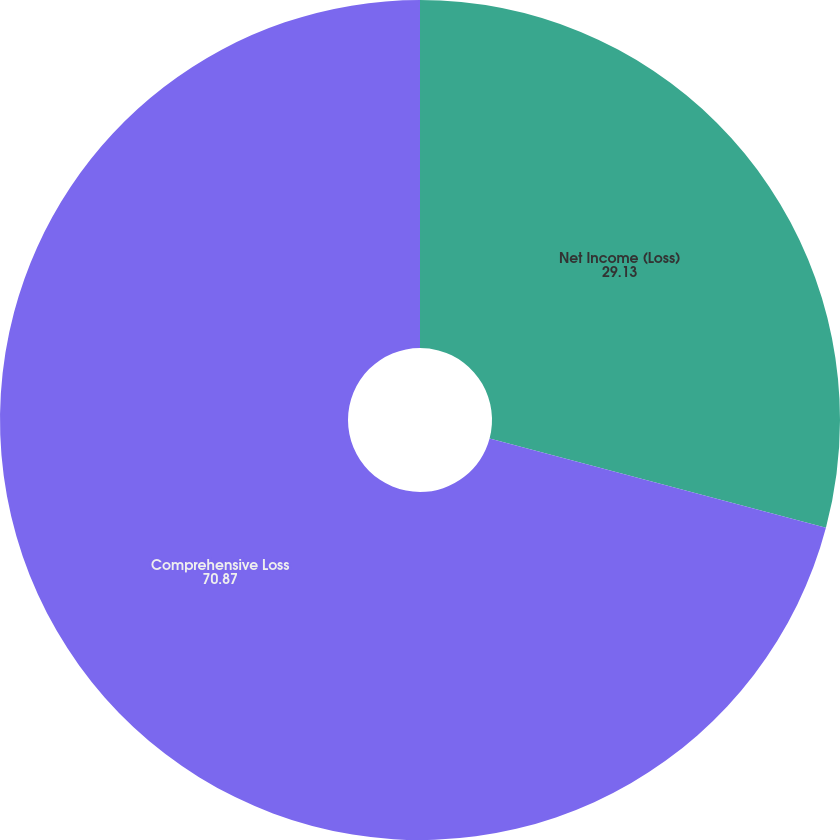<chart> <loc_0><loc_0><loc_500><loc_500><pie_chart><fcel>Net Income (Loss)<fcel>Comprehensive Loss<nl><fcel>29.13%<fcel>70.87%<nl></chart> 